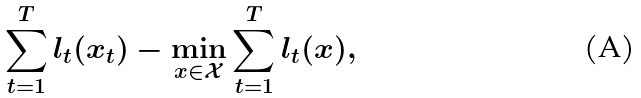<formula> <loc_0><loc_0><loc_500><loc_500>\sum _ { t = 1 } ^ { T } l _ { t } ( x _ { t } ) - \min _ { x \in \mathcal { X } } \sum _ { t = 1 } ^ { T } l _ { t } ( x ) ,</formula> 